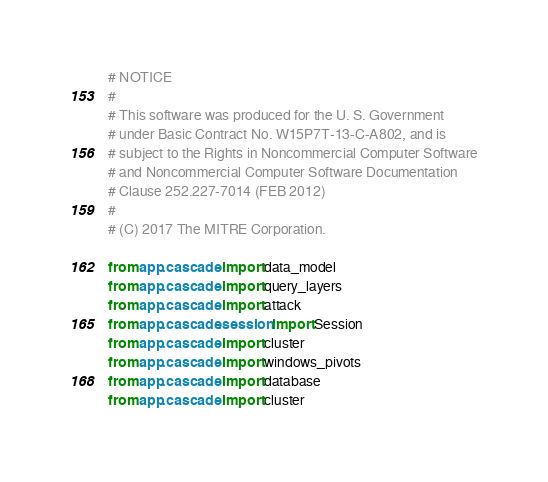<code> <loc_0><loc_0><loc_500><loc_500><_Python_># NOTICE
#
# This software was produced for the U. S. Government
# under Basic Contract No. W15P7T-13-C-A802, and is
# subject to the Rights in Noncommercial Computer Software
# and Noncommercial Computer Software Documentation
# Clause 252.227-7014 (FEB 2012)
#
# (C) 2017 The MITRE Corporation.

from app.cascade import data_model
from app.cascade import query_layers
from app.cascade import attack
from app.cascade.session import Session
from app.cascade import cluster
from app.cascade import windows_pivots
from app.cascade import database
from app.cascade import cluster</code> 